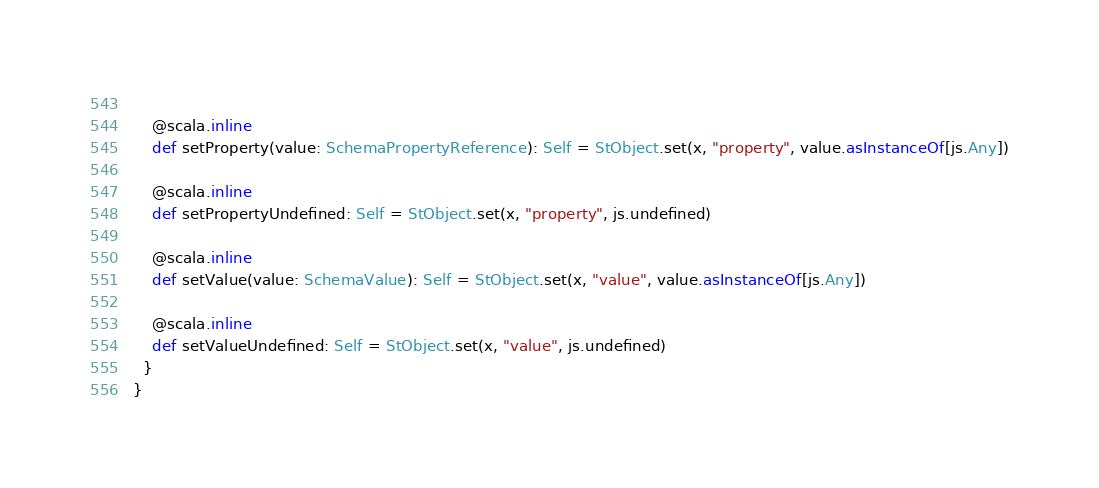<code> <loc_0><loc_0><loc_500><loc_500><_Scala_>    
    @scala.inline
    def setProperty(value: SchemaPropertyReference): Self = StObject.set(x, "property", value.asInstanceOf[js.Any])
    
    @scala.inline
    def setPropertyUndefined: Self = StObject.set(x, "property", js.undefined)
    
    @scala.inline
    def setValue(value: SchemaValue): Self = StObject.set(x, "value", value.asInstanceOf[js.Any])
    
    @scala.inline
    def setValueUndefined: Self = StObject.set(x, "value", js.undefined)
  }
}
</code> 